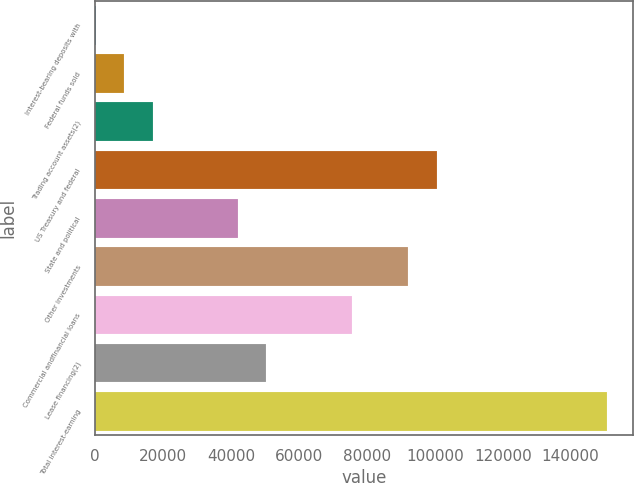Convert chart. <chart><loc_0><loc_0><loc_500><loc_500><bar_chart><fcel>Interest-bearing deposits with<fcel>Federal funds sold<fcel>Trading account assets(2)<fcel>US Treasury and federal<fcel>State and political<fcel>Other investments<fcel>Commercial andfinancial loans<fcel>Lease financing(2)<fcel>Total interest-earning<nl><fcel>167<fcel>8537.9<fcel>16908.8<fcel>100618<fcel>42021.5<fcel>92246.9<fcel>75505.1<fcel>50392.4<fcel>150843<nl></chart> 